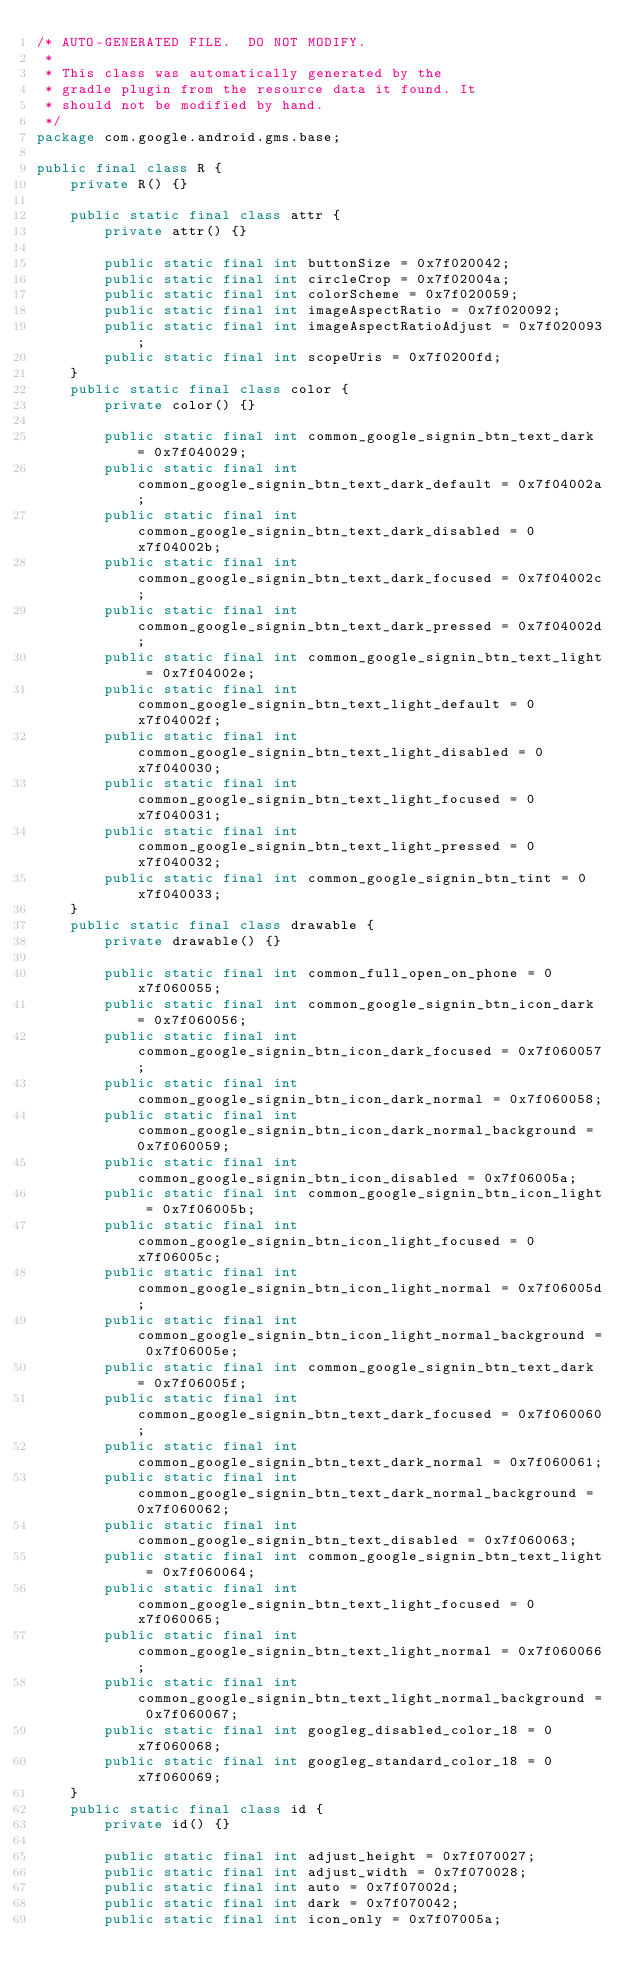<code> <loc_0><loc_0><loc_500><loc_500><_Java_>/* AUTO-GENERATED FILE.  DO NOT MODIFY.
 *
 * This class was automatically generated by the
 * gradle plugin from the resource data it found. It
 * should not be modified by hand.
 */
package com.google.android.gms.base;

public final class R {
    private R() {}

    public static final class attr {
        private attr() {}

        public static final int buttonSize = 0x7f020042;
        public static final int circleCrop = 0x7f02004a;
        public static final int colorScheme = 0x7f020059;
        public static final int imageAspectRatio = 0x7f020092;
        public static final int imageAspectRatioAdjust = 0x7f020093;
        public static final int scopeUris = 0x7f0200fd;
    }
    public static final class color {
        private color() {}

        public static final int common_google_signin_btn_text_dark = 0x7f040029;
        public static final int common_google_signin_btn_text_dark_default = 0x7f04002a;
        public static final int common_google_signin_btn_text_dark_disabled = 0x7f04002b;
        public static final int common_google_signin_btn_text_dark_focused = 0x7f04002c;
        public static final int common_google_signin_btn_text_dark_pressed = 0x7f04002d;
        public static final int common_google_signin_btn_text_light = 0x7f04002e;
        public static final int common_google_signin_btn_text_light_default = 0x7f04002f;
        public static final int common_google_signin_btn_text_light_disabled = 0x7f040030;
        public static final int common_google_signin_btn_text_light_focused = 0x7f040031;
        public static final int common_google_signin_btn_text_light_pressed = 0x7f040032;
        public static final int common_google_signin_btn_tint = 0x7f040033;
    }
    public static final class drawable {
        private drawable() {}

        public static final int common_full_open_on_phone = 0x7f060055;
        public static final int common_google_signin_btn_icon_dark = 0x7f060056;
        public static final int common_google_signin_btn_icon_dark_focused = 0x7f060057;
        public static final int common_google_signin_btn_icon_dark_normal = 0x7f060058;
        public static final int common_google_signin_btn_icon_dark_normal_background = 0x7f060059;
        public static final int common_google_signin_btn_icon_disabled = 0x7f06005a;
        public static final int common_google_signin_btn_icon_light = 0x7f06005b;
        public static final int common_google_signin_btn_icon_light_focused = 0x7f06005c;
        public static final int common_google_signin_btn_icon_light_normal = 0x7f06005d;
        public static final int common_google_signin_btn_icon_light_normal_background = 0x7f06005e;
        public static final int common_google_signin_btn_text_dark = 0x7f06005f;
        public static final int common_google_signin_btn_text_dark_focused = 0x7f060060;
        public static final int common_google_signin_btn_text_dark_normal = 0x7f060061;
        public static final int common_google_signin_btn_text_dark_normal_background = 0x7f060062;
        public static final int common_google_signin_btn_text_disabled = 0x7f060063;
        public static final int common_google_signin_btn_text_light = 0x7f060064;
        public static final int common_google_signin_btn_text_light_focused = 0x7f060065;
        public static final int common_google_signin_btn_text_light_normal = 0x7f060066;
        public static final int common_google_signin_btn_text_light_normal_background = 0x7f060067;
        public static final int googleg_disabled_color_18 = 0x7f060068;
        public static final int googleg_standard_color_18 = 0x7f060069;
    }
    public static final class id {
        private id() {}

        public static final int adjust_height = 0x7f070027;
        public static final int adjust_width = 0x7f070028;
        public static final int auto = 0x7f07002d;
        public static final int dark = 0x7f070042;
        public static final int icon_only = 0x7f07005a;</code> 